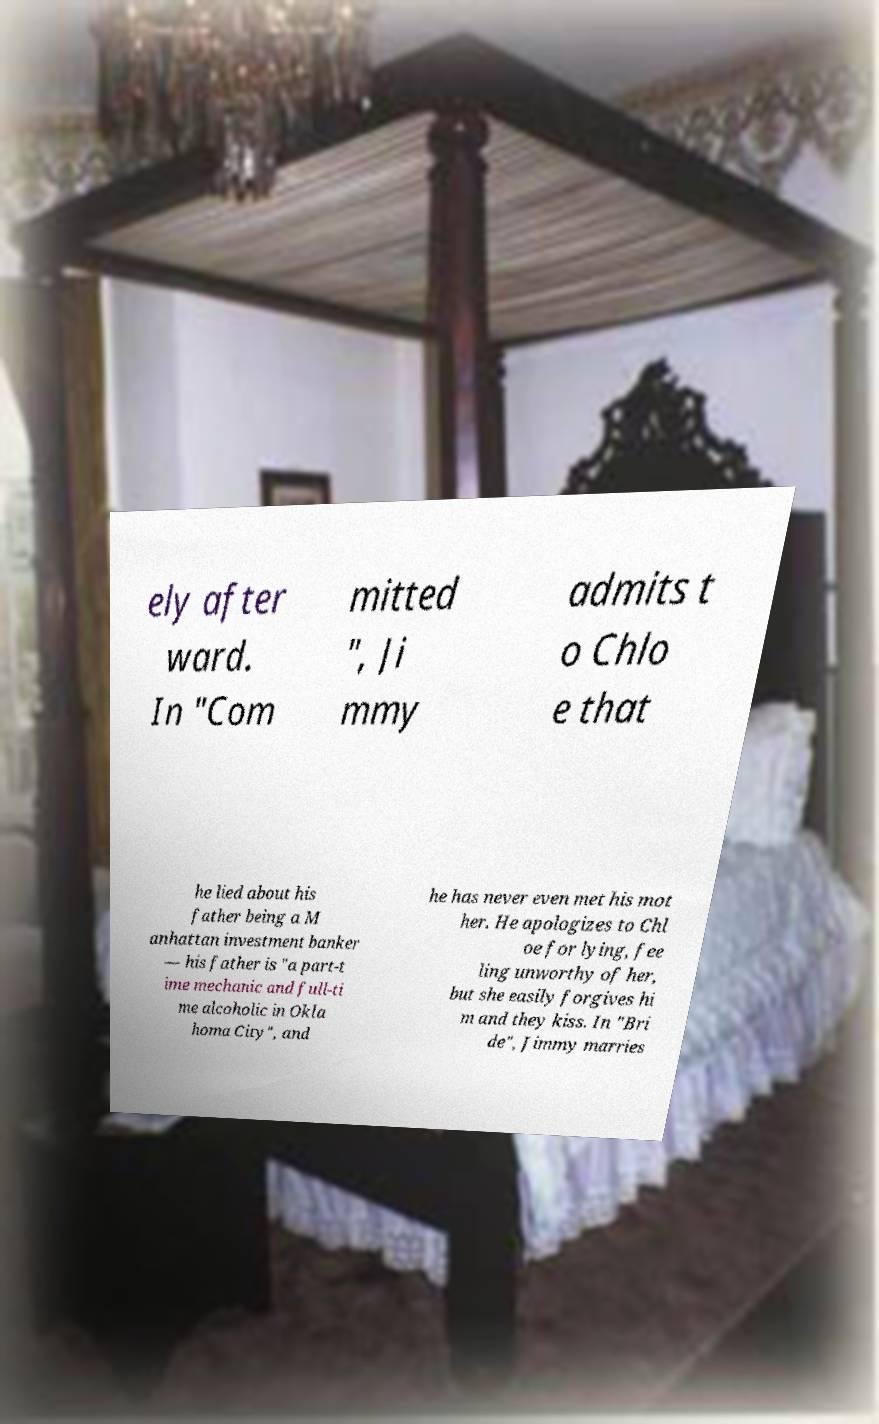Could you assist in decoding the text presented in this image and type it out clearly? ely after ward. In "Com mitted ", Ji mmy admits t o Chlo e that he lied about his father being a M anhattan investment banker — his father is "a part-t ime mechanic and full-ti me alcoholic in Okla homa City", and he has never even met his mot her. He apologizes to Chl oe for lying, fee ling unworthy of her, but she easily forgives hi m and they kiss. In "Bri de", Jimmy marries 